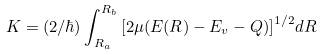Convert formula to latex. <formula><loc_0><loc_0><loc_500><loc_500>K = ( 2 / \hbar { ) } \int _ { R _ { a } } ^ { R _ { b } } { [ 2 \mu ( E ( R ) - E _ { v } - Q ) ] } ^ { 1 / 2 } d R</formula> 